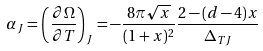<formula> <loc_0><loc_0><loc_500><loc_500>\alpha _ { J } = \left ( \frac { \partial \Omega } { \partial T } \right ) _ { J } = - \frac { 8 \pi \sqrt { x } } { ( 1 + x ) ^ { 2 } } \frac { 2 - ( d - 4 ) x } { \Delta _ { T J } }</formula> 